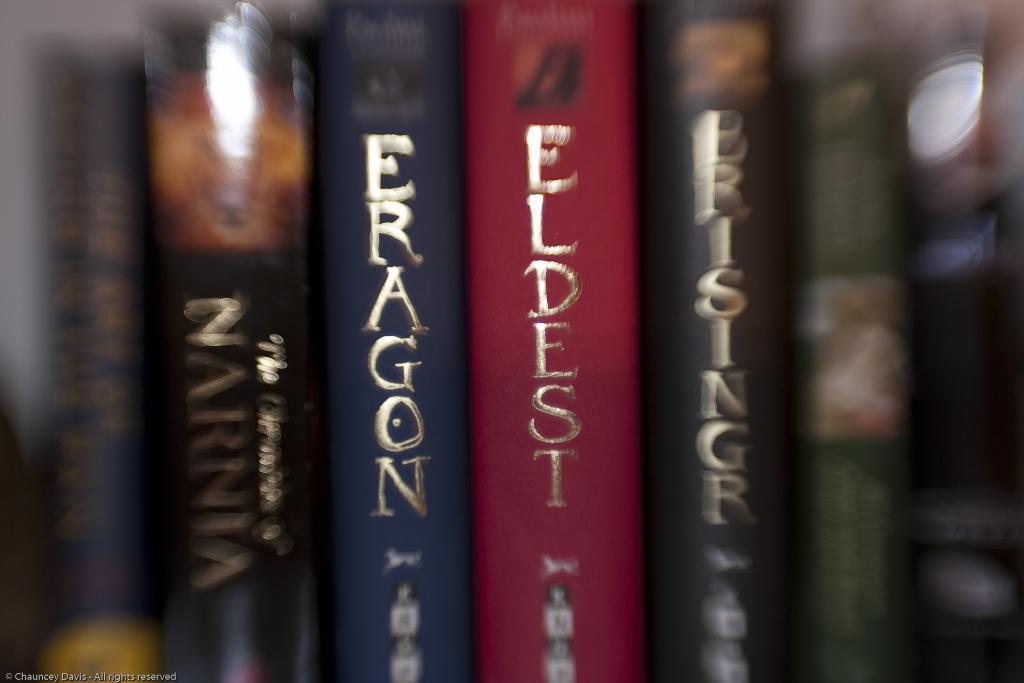What is the title of the red book in the center?
Make the answer very short. Eldest. 